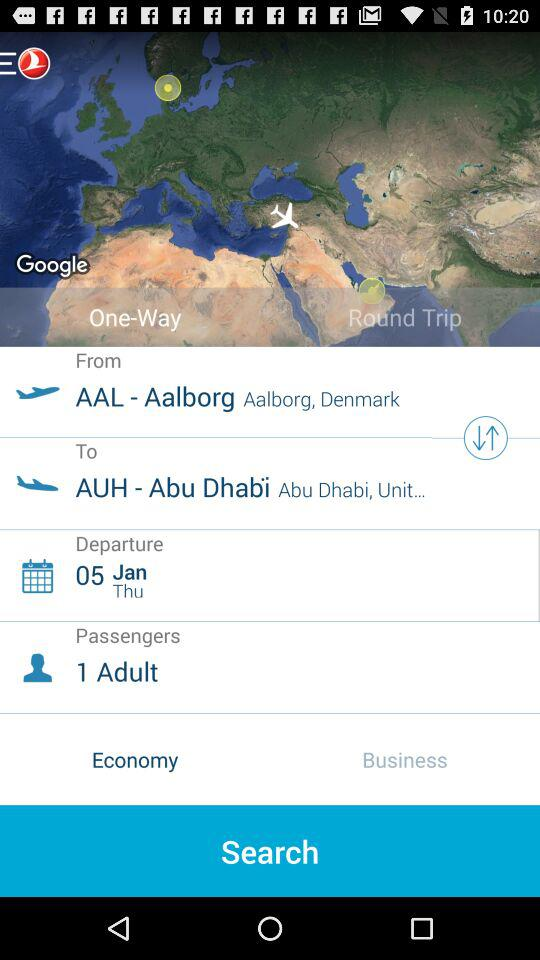How many passengers are boarding the flight? The number of passengers boarding the flight is 1. 